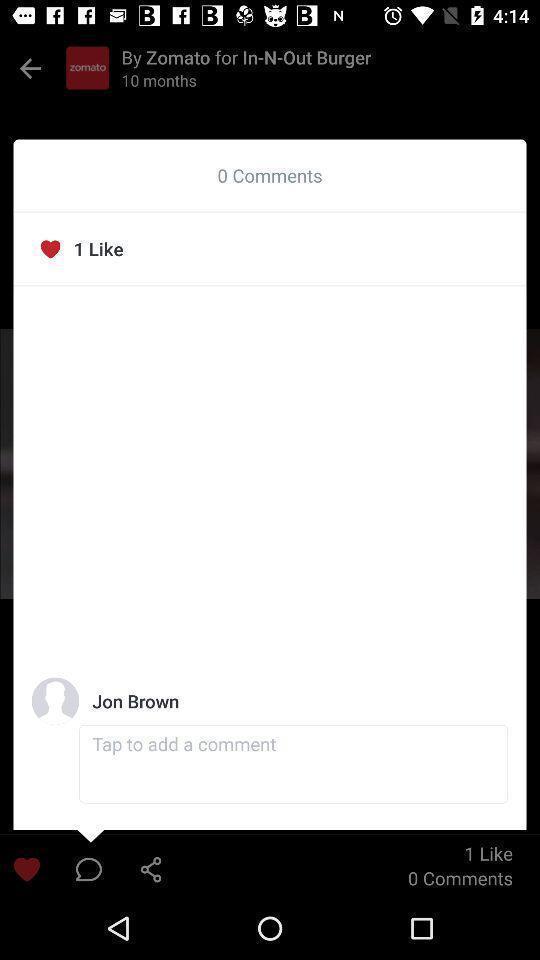Describe this image in words. Popup of chat with profile in the application. 